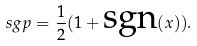Convert formula to latex. <formula><loc_0><loc_0><loc_500><loc_500>\ s g p = \frac { 1 } { 2 } ( 1 + \text {sgn} ( x ) ) .</formula> 